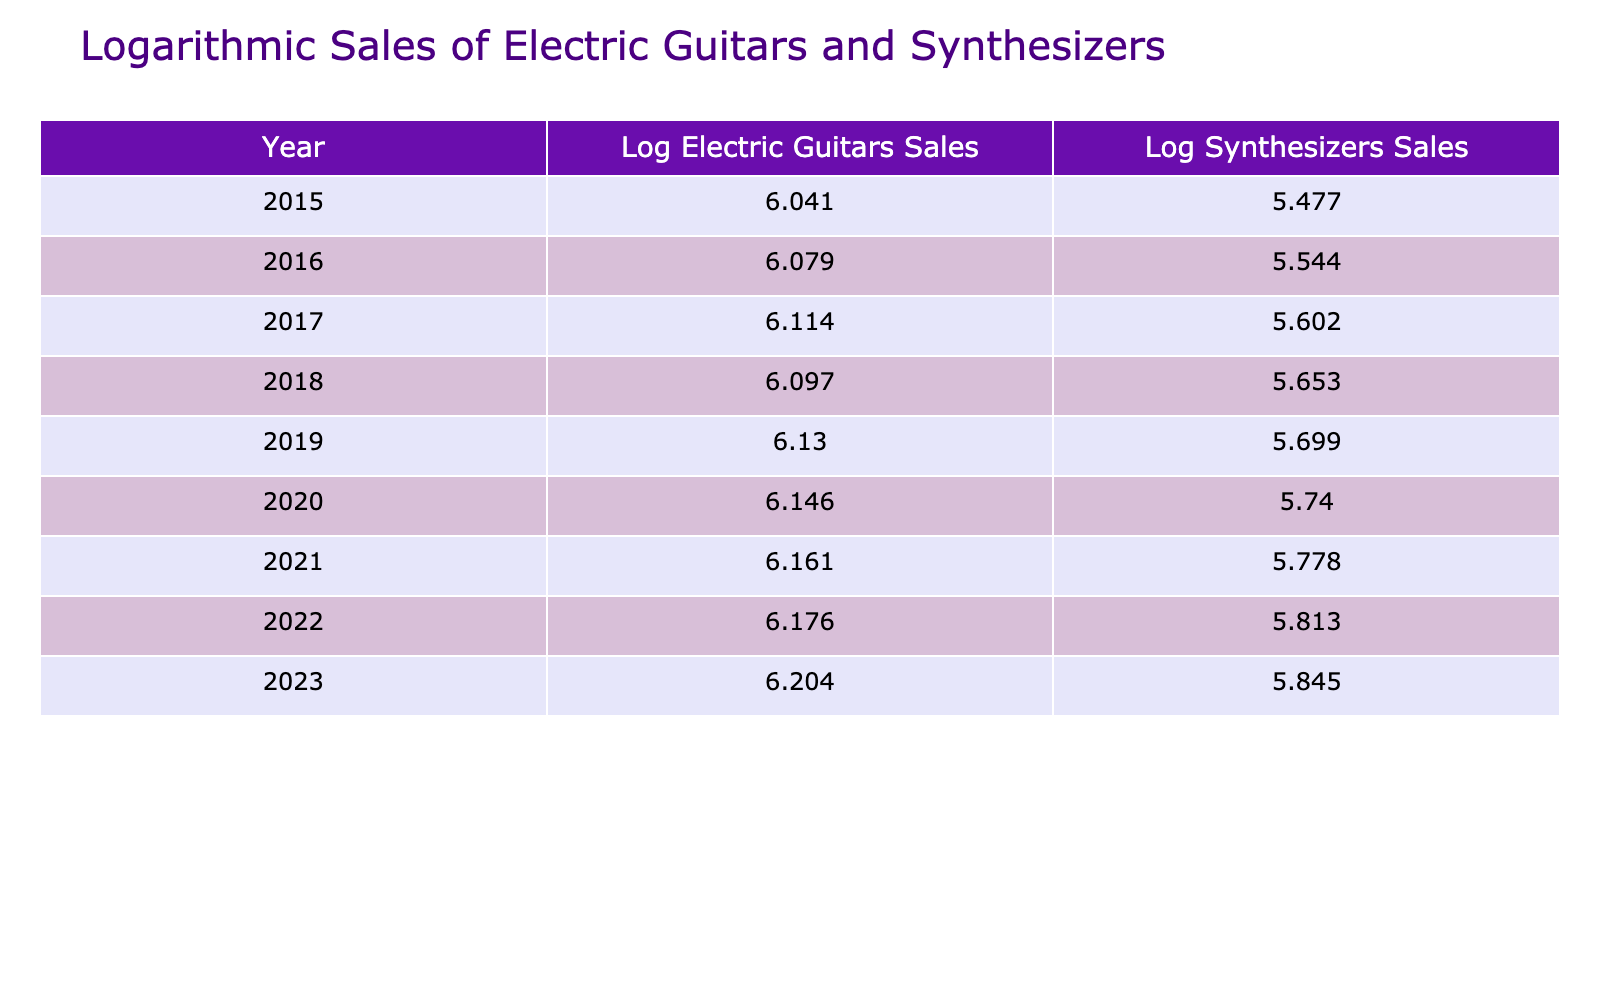What is the logarithmic sales value of electric guitars in 2020? The table shows that in 2020, the sales figure for electric guitars was 1400000 units. Applying logarithm to this value gives us Log(1400000) ≈ 6.146.
Answer: 6.146 What was the sales figure of synthesizers in 2019? According to the table, the synthesizers sold in 2019 were 500000 units.
Answer: 500000 In which year did electric guitar sales first exceed 1.3 million units? Looking at the sales figures, electric guitar sales exceeded 1.3 million units for the first time in 2017.
Answer: 2017 What was the average logarithmic sales value for synthesizers from 2015 to 2023? First, we find the logarithmic values for synthesizers from 2015 to 2023 which are approximately 5.477, 5.544, 5.602, 5.653, 5.699, 5.740, 5.778, 5.806, and 5.845 respectively. The sum of these values is approximately 45.344, and dividing by 9 gives an average of about 5.038.
Answer: 5.038 Did the logarithmic values for electric guitars ever decrease from one year to the next between 2015 and 2023? Reviewing the logarithmic values shows that each year’s value for electric guitars is greater than the previous year’s. Hence, the logarithmic values did not decrease.
Answer: No Which year had the highest logarithmic sales value for synthesizers? The table indicates that the highest sales value for synthesizers was in 2023, with a logarithmic value of approximately 5.845.
Answer: 2023 What's the difference in logarithmic sales values between electric guitars and synthesizers in 2022? For 2022, the logarithmic sales value of electric guitars is approximately 5.176, and for synthesizers, it is approximately 5.813. The difference is about 5.176 - 5.813 = -0.637.
Answer: -0.637 Which year had the smallest difference in sales units between electric guitars and synthesizers? By examining the sales figures, the smallest difference is found in 2015, with electric guitars selling 1100000 and synthesizers selling 300000, resulting in a difference of 800000 units.
Answer: 2015 What are the logarithmic sales values for electric guitars in 2017 and 2021 combined? The logarithmic sales value for electric guitars in 2017 is approximately 6.113 and in 2021 is approximately 6.162. Adding these gives us about 12.275.
Answer: 12.275 